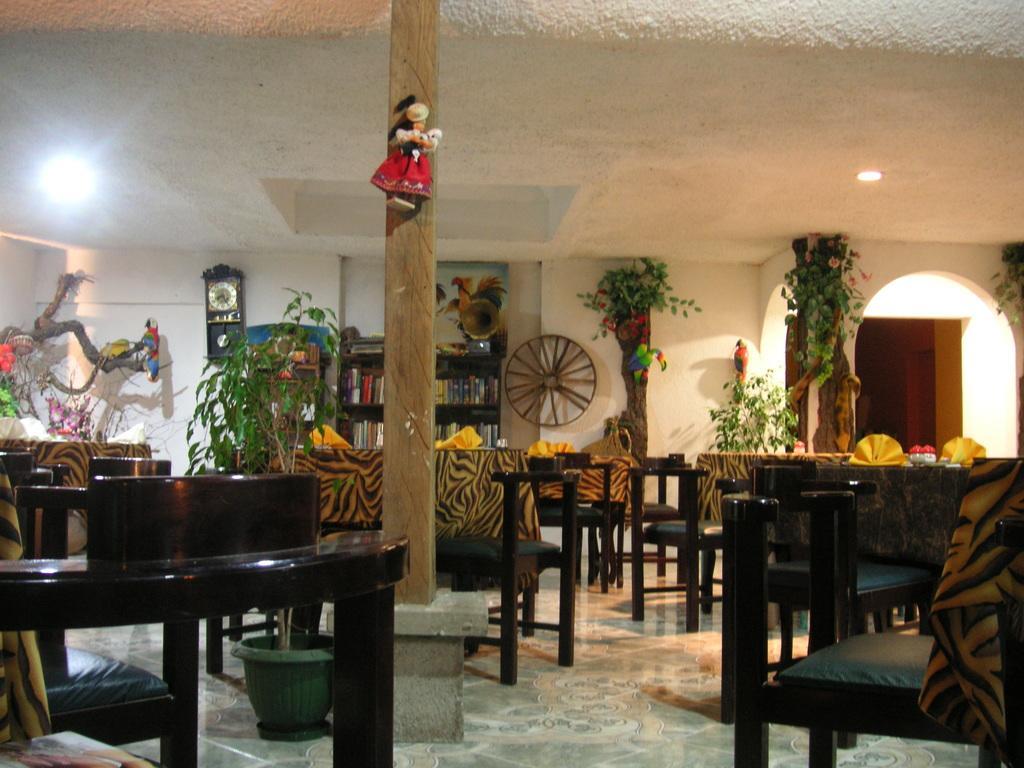Can you describe this image briefly? In the center of the image there are chairs and tables. At the top of the image there is ceiling. There are plants. In the background of the image there is a clock on the wall. There is a bookshelf. At the bottom of the image there is floor. 